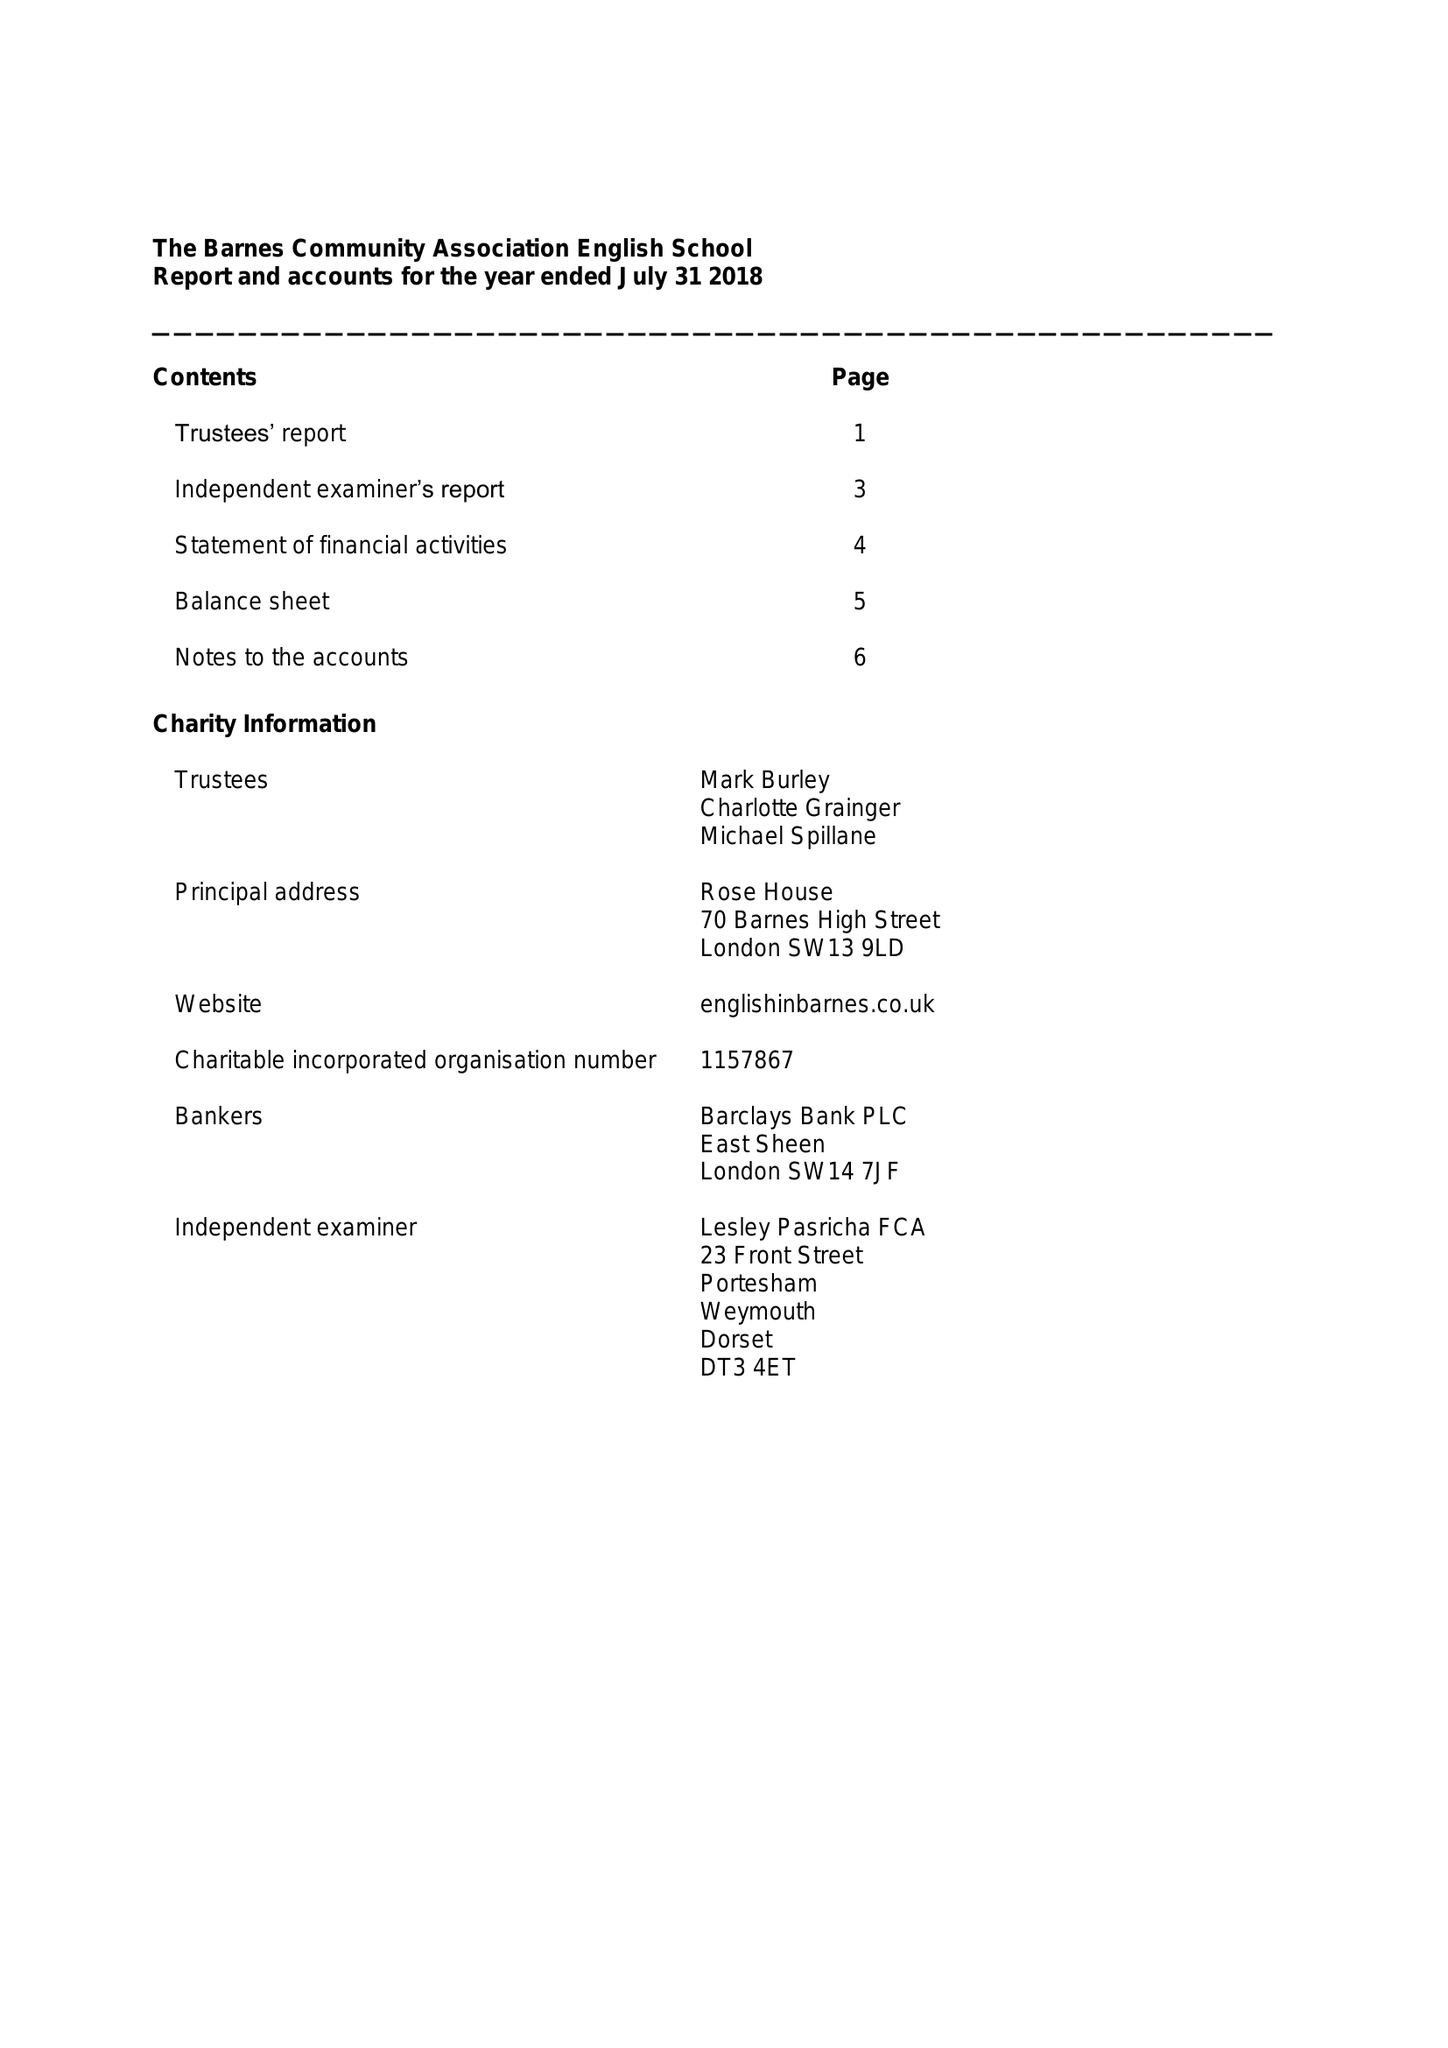What is the value for the address__postcode?
Answer the question using a single word or phrase. SW13 9LD 